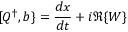Convert formula to latex. <formula><loc_0><loc_0><loc_500><loc_500>[ Q ^ { \dagger } , b \} = { \frac { d x } { d t } } + i \Re \{ W \}</formula> 